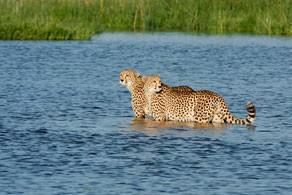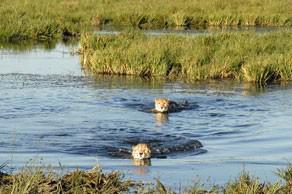The first image is the image on the left, the second image is the image on the right. Analyze the images presented: Is the assertion "Each image shows at least one spotted wild cat leaning to drink out of a manmade swimming pool." valid? Answer yes or no. No. The first image is the image on the left, the second image is the image on the right. For the images displayed, is the sentence "There is a leopard looking into a swimming pool in each image." factually correct? Answer yes or no. No. 